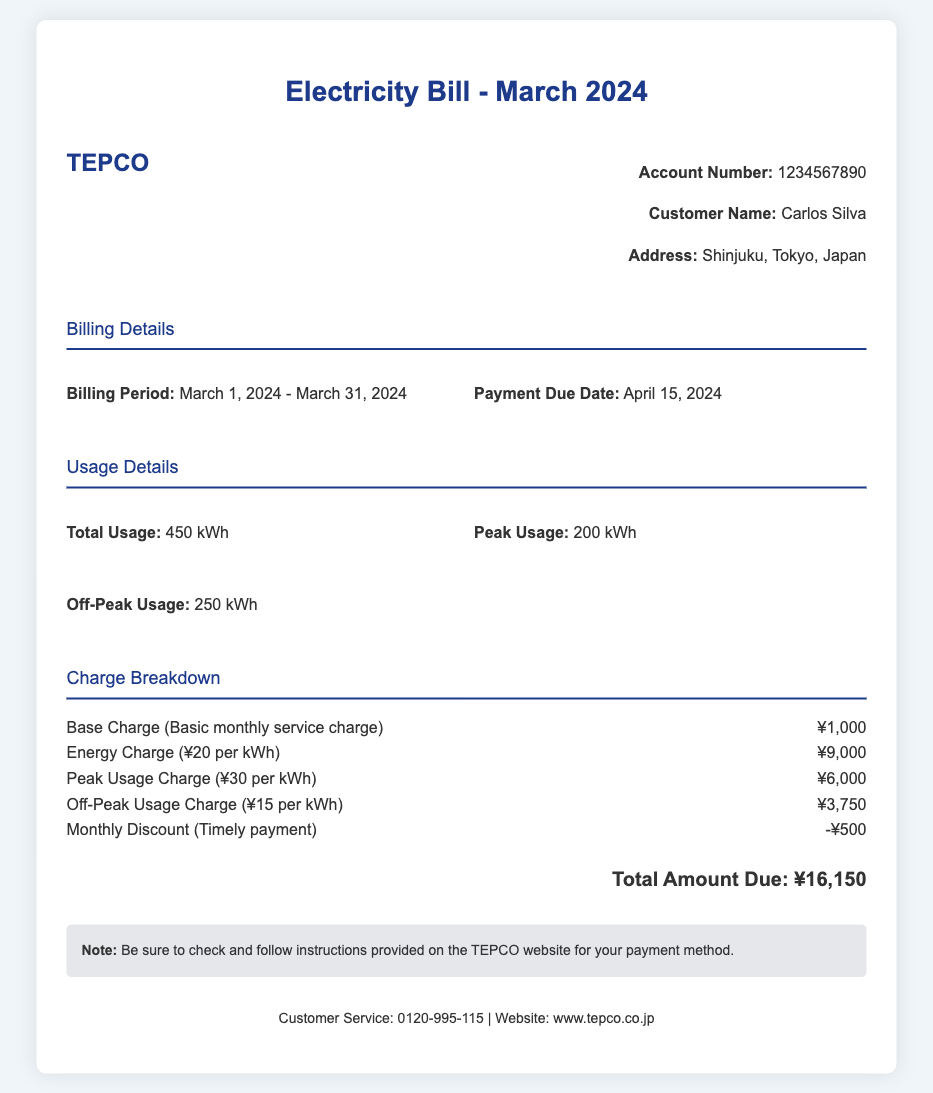What is the billing period? The billing period is specified in the document, which is from March 1, 2024, to March 31, 2024.
Answer: March 1, 2024 - March 31, 2024 What is the peak usage? The peak usage is clearly stated in the usage details section of the document.
Answer: 200 kWh What is the total amount due? The total amount due is listed at the bottom of the charge breakdown section.
Answer: ¥16,150 What is the amount charged for off-peak usage? The charge for off-peak usage can be found in the charge breakdown section.
Answer: ¥3,750 What type of document is this? The title of the document indicates the nature of the document clearly.
Answer: Utility Bill What discount was applied to the bill? The charge breakdown includes a line for the discount applied.
Answer: -¥500 What is the customer service phone number? The contact details include a customer service phone number at the bottom of the document.
Answer: 0120-995-115 What is the base charge amount? The charge breakdown lists the base charge amount explicitly.
Answer: ¥1,000 